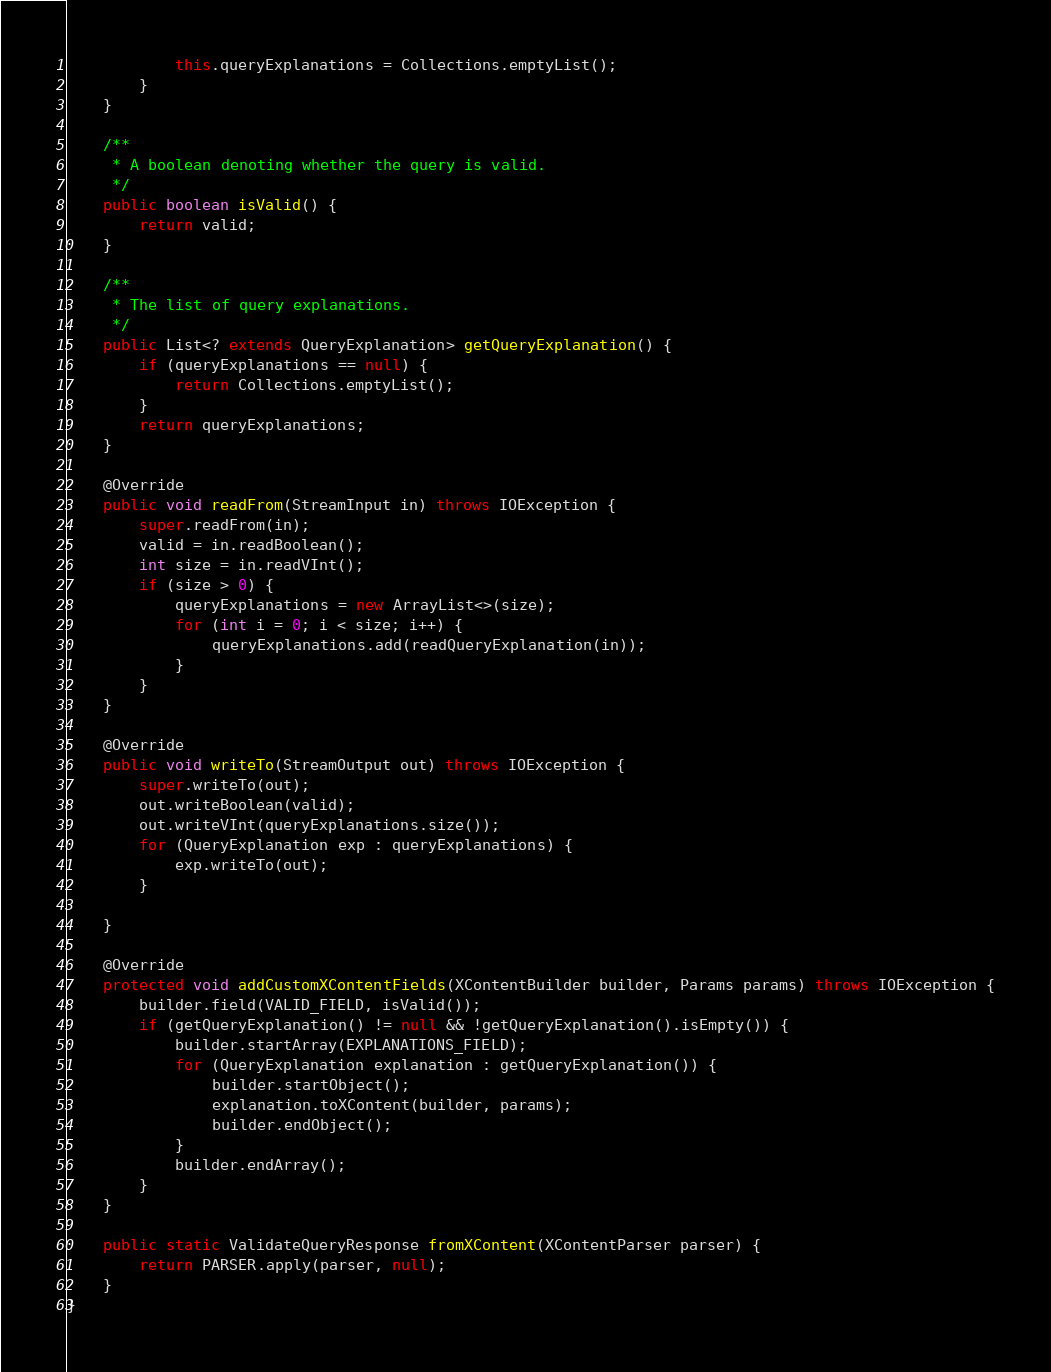<code> <loc_0><loc_0><loc_500><loc_500><_Java_>            this.queryExplanations = Collections.emptyList();
        }
    }

    /**
     * A boolean denoting whether the query is valid.
     */
    public boolean isValid() {
        return valid;
    }

    /**
     * The list of query explanations.
     */
    public List<? extends QueryExplanation> getQueryExplanation() {
        if (queryExplanations == null) {
            return Collections.emptyList();
        }
        return queryExplanations;
    }

    @Override
    public void readFrom(StreamInput in) throws IOException {
        super.readFrom(in);
        valid = in.readBoolean();
        int size = in.readVInt();
        if (size > 0) {
            queryExplanations = new ArrayList<>(size);
            for (int i = 0; i < size; i++) {
                queryExplanations.add(readQueryExplanation(in));
            }
        }
    }

    @Override
    public void writeTo(StreamOutput out) throws IOException {
        super.writeTo(out);
        out.writeBoolean(valid);
        out.writeVInt(queryExplanations.size());
        for (QueryExplanation exp : queryExplanations) {
            exp.writeTo(out);
        }

    }

    @Override
    protected void addCustomXContentFields(XContentBuilder builder, Params params) throws IOException {
        builder.field(VALID_FIELD, isValid());
        if (getQueryExplanation() != null && !getQueryExplanation().isEmpty()) {
            builder.startArray(EXPLANATIONS_FIELD);
            for (QueryExplanation explanation : getQueryExplanation()) {
                builder.startObject();
                explanation.toXContent(builder, params);
                builder.endObject();
            }
            builder.endArray();
        }
    }

    public static ValidateQueryResponse fromXContent(XContentParser parser) {
        return PARSER.apply(parser, null);
    }
}
</code> 